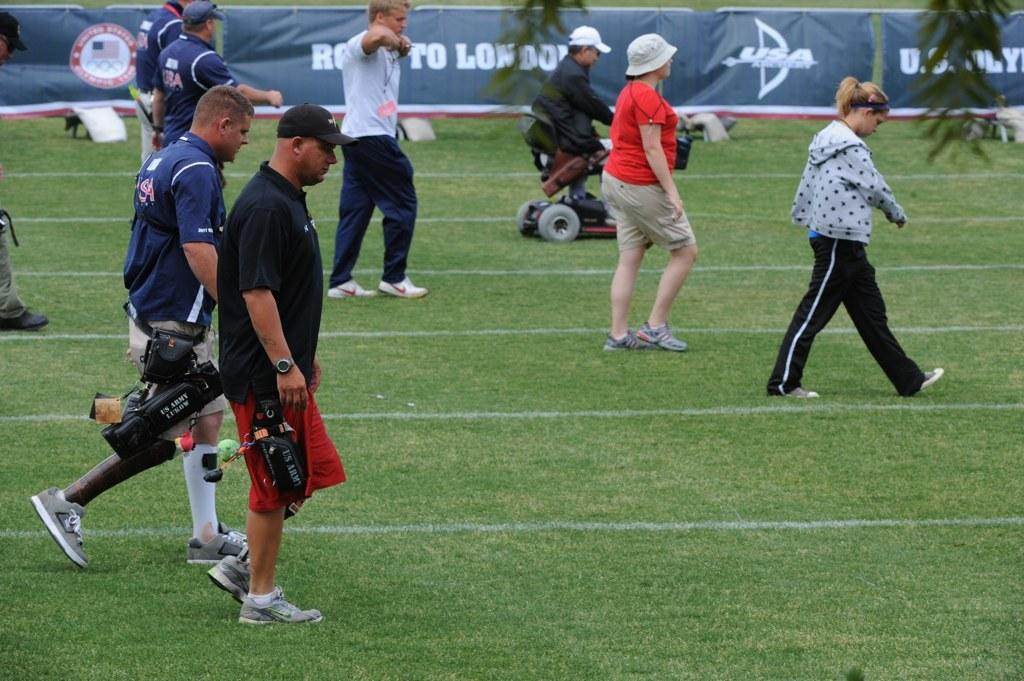<image>
Give a short and clear explanation of the subsequent image. People standing on a field with the word "USA" in the back. 